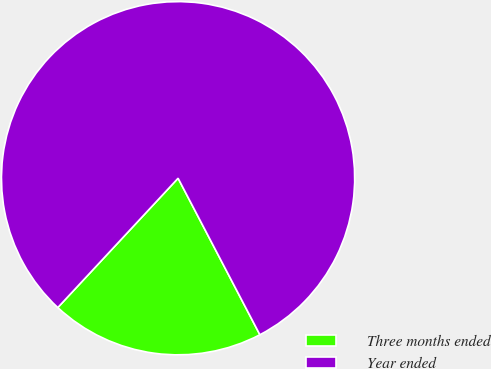Convert chart. <chart><loc_0><loc_0><loc_500><loc_500><pie_chart><fcel>Three months ended<fcel>Year ended<nl><fcel>19.59%<fcel>80.41%<nl></chart> 